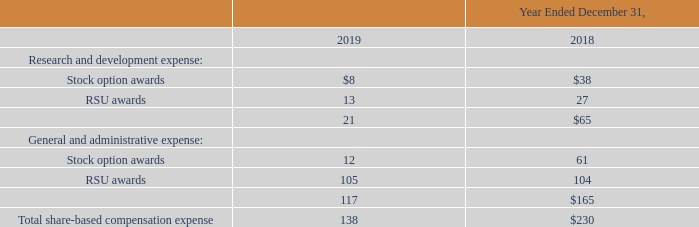Share-based Compensation Expense
We have several share-based compensation plans covering stock options and RSUs for our employees and directors, which are described more fully in Note 11.
We measure our compensation cost related to share-based payment transactions based on fair value of the equity or liability classified instrument. For purposes of estimating the fair value of each stock option unit on the date of grant, we utilize the Black-Scholes option-pricing model. Option valuation models require the input of highly subjective assumptions including the expected volatility factor of the market price of our common stock (as determined by reviewing our historical public market closing prices). Our accounting for share-based compensation for RSUs is based on the closing market price of our common stock on the date of grant.
Our total share-based compensation expense recognized in the Company’s results of operations from non-cash and cash-portioned instruments issued to our employees and directors comprised the following (in thousands):
How is share-based compensation expense measured? We measure our compensation cost related to share-based payment transactions based on fair value of the equity or liability classified instrument. What are the types of share-based compensation plans? We have several share-based compensation plans covering stock options and rsus for our employees and directors. What was the total share-based compensation in 2018?
Answer scale should be: thousand. 138. How much did the stock-based compensation expense in the general and administrative operations decreased from 2018 to 2019?
Answer scale should be: thousand. 165 - 117 
Answer: 48. How much percent did the total share-based compensation decreased from 2018 to 2019?
Answer scale should be: percent. (230 - 138) / 138 
Answer: 66.67. What proportion of the total stock-based compensation expense is made up from the research and development operations in 2019?
Answer scale should be: percent. 21/138 
Answer: 15.22. 